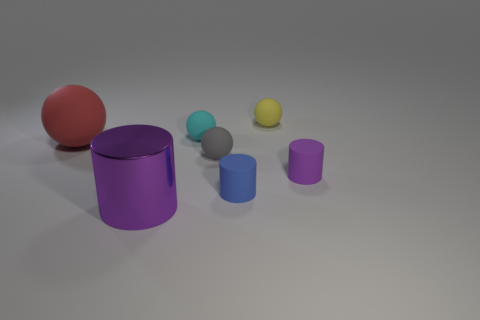Subtract all gray rubber balls. How many balls are left? 3 Subtract 1 cylinders. How many cylinders are left? 2 Add 3 rubber cylinders. How many objects exist? 10 Subtract all blue cylinders. How many cylinders are left? 2 Subtract 0 purple balls. How many objects are left? 7 Subtract all cylinders. How many objects are left? 4 Subtract all green balls. Subtract all brown cubes. How many balls are left? 4 Subtract all purple blocks. How many yellow spheres are left? 1 Subtract all tiny gray spheres. Subtract all red objects. How many objects are left? 5 Add 4 spheres. How many spheres are left? 8 